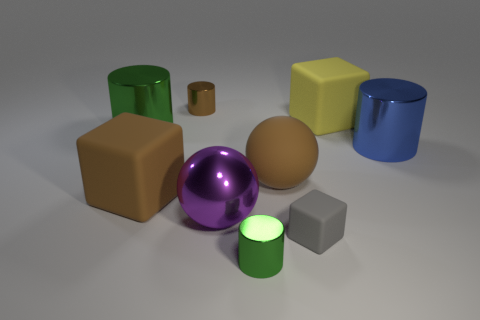There is a brown thing that is made of the same material as the purple ball; what is its size?
Offer a very short reply. Small. The brown metal thing is what size?
Provide a short and direct response. Small. Is the number of tiny things less than the number of large things?
Provide a short and direct response. Yes. What number of tiny things are the same color as the matte sphere?
Give a very brief answer. 1. There is a large block left of the matte ball; is it the same color as the big matte ball?
Provide a short and direct response. Yes. There is a large metallic object that is behind the big blue thing; what is its shape?
Provide a succinct answer. Cylinder. There is a small shiny cylinder that is in front of the brown matte sphere; is there a gray rubber thing in front of it?
Ensure brevity in your answer.  No. What number of green objects are made of the same material as the blue thing?
Your answer should be compact. 2. There is a brown matte thing that is to the right of the green thing in front of the green object that is behind the tiny green metallic cylinder; what is its size?
Offer a very short reply. Large. There is a gray rubber thing; what number of big purple things are in front of it?
Offer a very short reply. 0. 